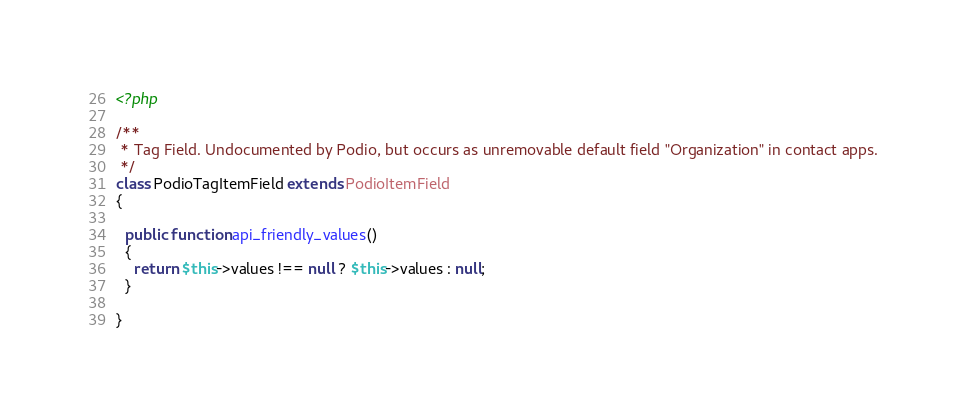<code> <loc_0><loc_0><loc_500><loc_500><_PHP_><?php

/**
 * Tag Field. Undocumented by Podio, but occurs as unremovable default field "Organization" in contact apps.
 */
class PodioTagItemField extends PodioItemField
{

  public function api_friendly_values()
  {
    return $this->values !== null ? $this->values : null;
  }

}</code> 